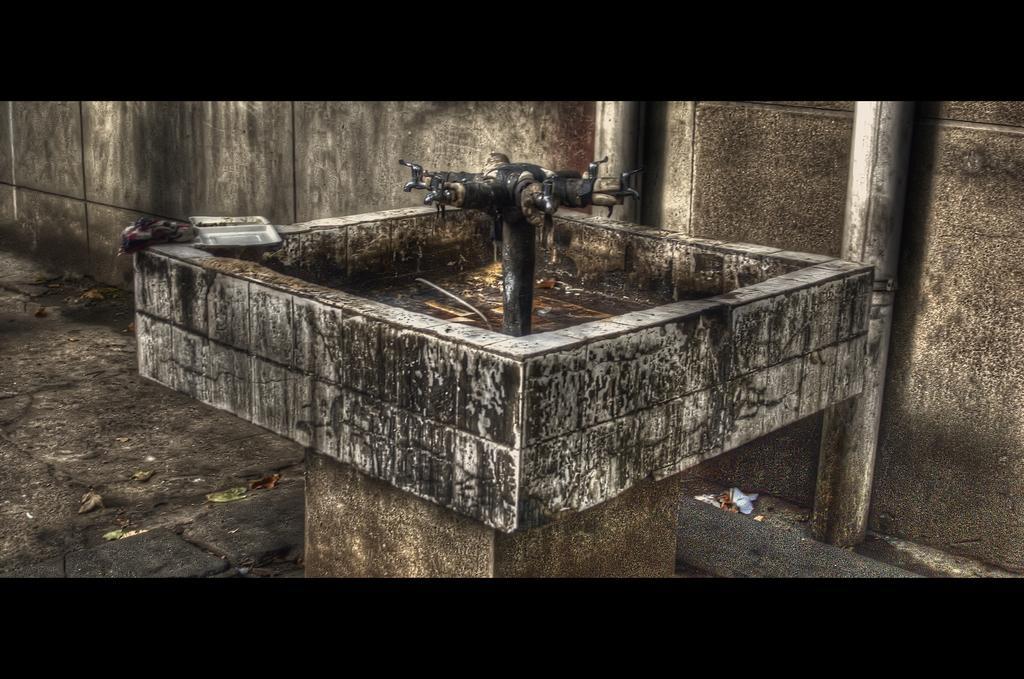Please provide a concise description of this image. In this image I can see a sink and I can also see few taps. Background I can see the wall in gray and black color. 